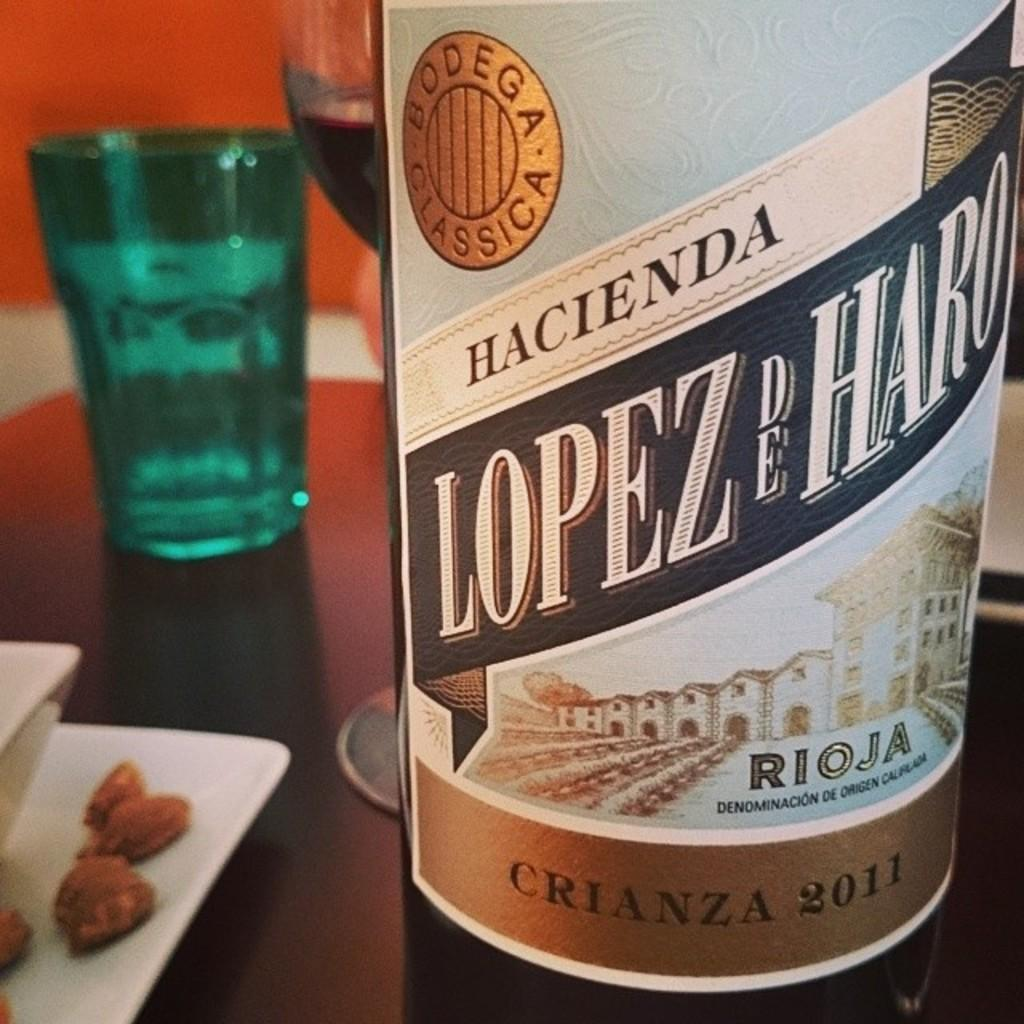<image>
Write a terse but informative summary of the picture. A bottle of Lopez De Haro sits on a table near some almonds 